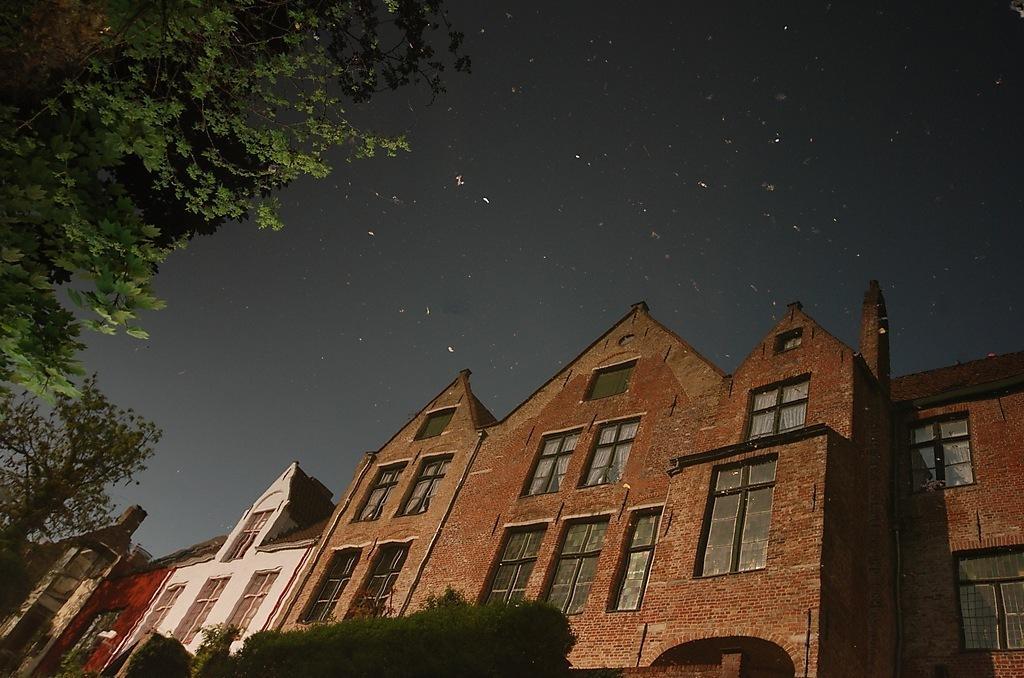Could you give a brief overview of what you see in this image? In this picture we can see there are buildings. In front of the buildings there are trees. Behind the buildings there is the sky. 